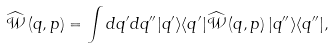<formula> <loc_0><loc_0><loc_500><loc_500>\widehat { \mathcal { W } } \left ( q , p \right ) = \int d q ^ { \prime } d q ^ { \prime \prime } | q ^ { \prime } \rangle \langle q ^ { \prime } | \widehat { \mathcal { W } } \left ( q , p \right ) | q ^ { \prime \prime } \rangle \langle q ^ { \prime \prime } | ,</formula> 